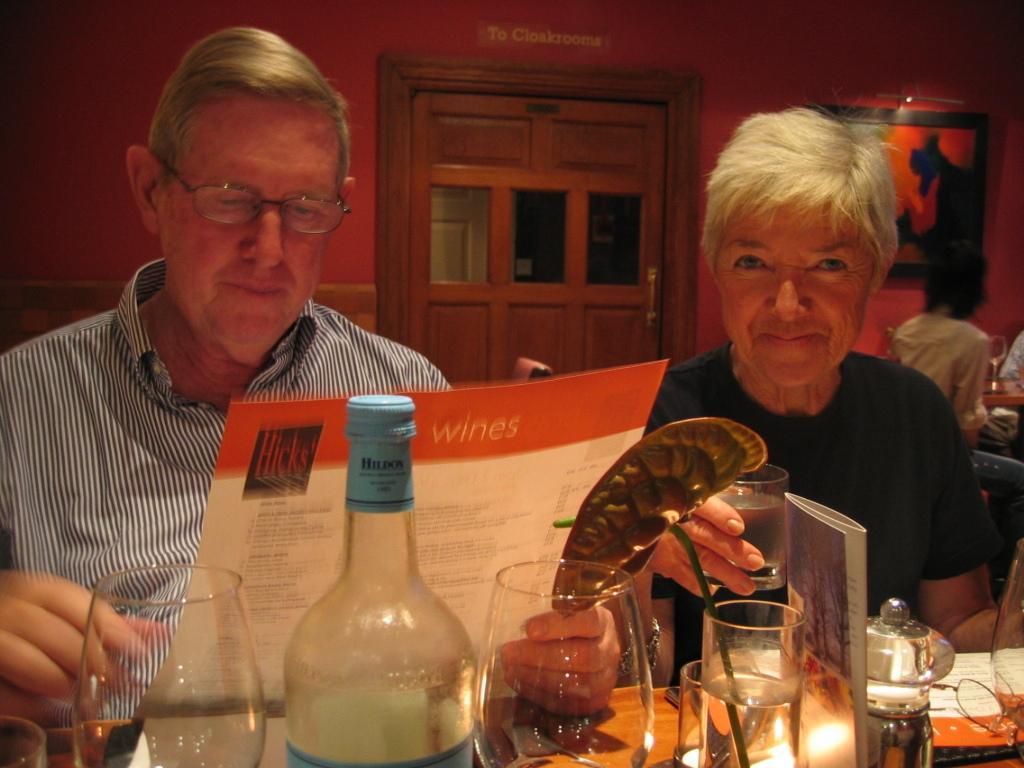Describe this image in one or two sentences. There is a man wearing specs is holding a menu card. Another lady is sitting next to him holding a glass. In front of him there is a table. On the table there are glass bottle, glasses, a glass with a flower, candle. In the background there is a red wall, door, also a painting is on the wall. 